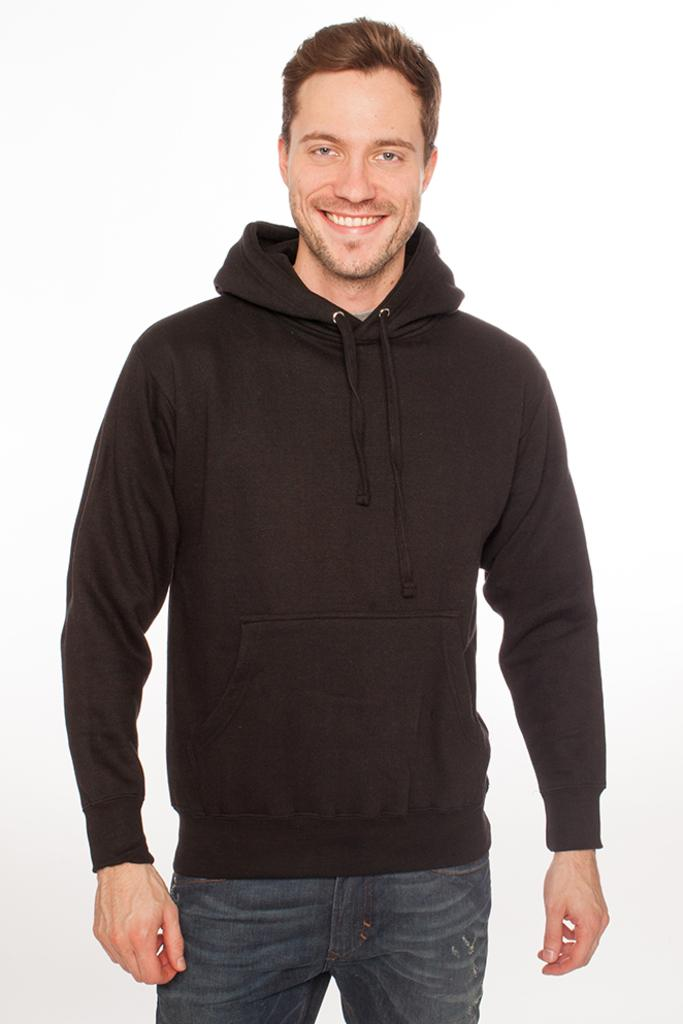Who or what is present in the image? There is a person in the image. What can be seen in the background of the image? There is a wall in the background of the image. What type of ear is visible on the person in the image? There is no ear visible on the person in the image. What season is depicted in the image? The provided facts do not mention any season or weather-related details, so it cannot be determined from the image. 